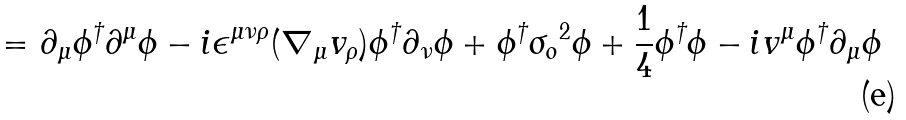Convert formula to latex. <formula><loc_0><loc_0><loc_500><loc_500>= \partial _ { \mu } \phi ^ { \dagger } \partial ^ { \mu } \phi - i \epsilon ^ { \mu \nu \rho } ( \nabla _ { \mu } v _ { \rho } ) \phi ^ { \dagger } \partial _ { \nu } \phi + \phi ^ { \dagger } { \sigma _ { o } } ^ { 2 } \phi + \frac { 1 } { 4 } \phi ^ { \dagger } \phi - i v ^ { \mu } \phi ^ { \dagger } \partial _ { \mu } \phi</formula> 